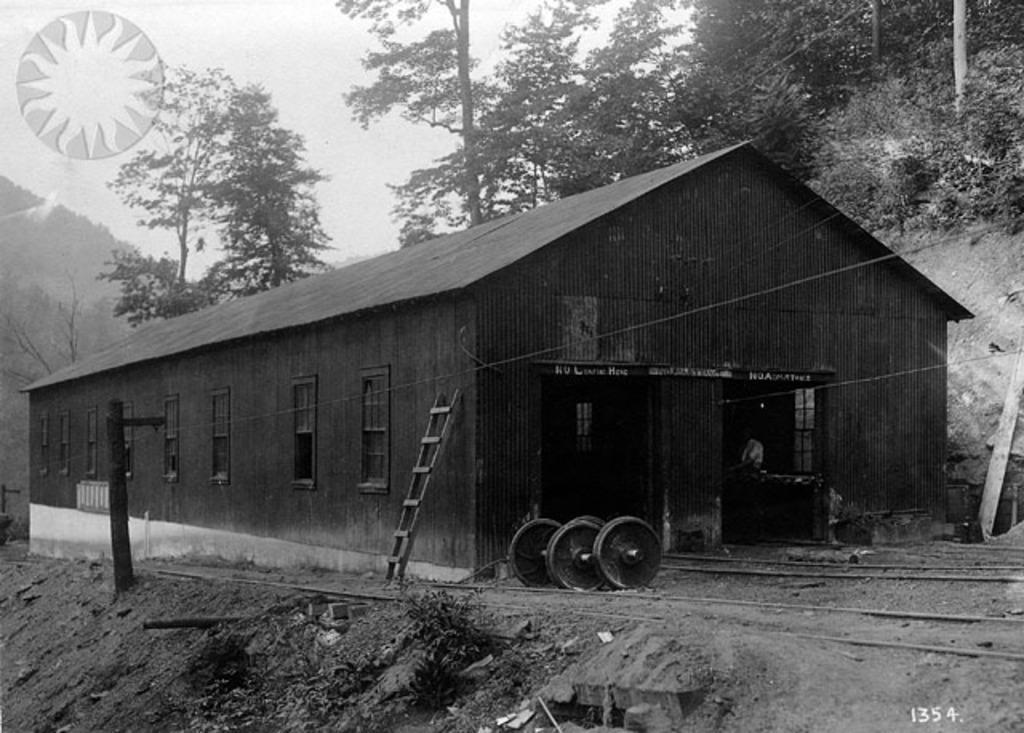Can you describe this image briefly? This is a black and white picture. Here we can see a shed, ladder, windows, boards, and trees. There is a watermark. In the background there is sky. 